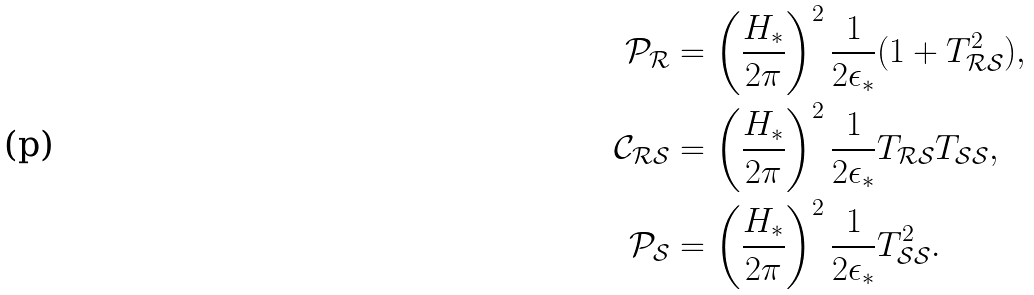<formula> <loc_0><loc_0><loc_500><loc_500>\mathcal { P } _ { \mathcal { R } } & = \left ( \frac { H _ { * } } { 2 \pi } \right ) ^ { 2 } \frac { 1 } { 2 \epsilon _ { * } } ( 1 + T _ { \mathcal { R S } } ^ { 2 } ) , \\ \mathcal { C } _ { \mathcal { R S } } & = \left ( \frac { H _ { * } } { 2 \pi } \right ) ^ { 2 } \frac { 1 } { 2 \epsilon _ { * } } T _ { \mathcal { R S } } T _ { \mathcal { S S } } , \\ \mathcal { P } _ { \mathcal { S } } & = \left ( \frac { H _ { * } } { 2 \pi } \right ) ^ { 2 } \frac { 1 } { 2 \epsilon _ { * } } T _ { \mathcal { S S } } ^ { 2 } .</formula> 